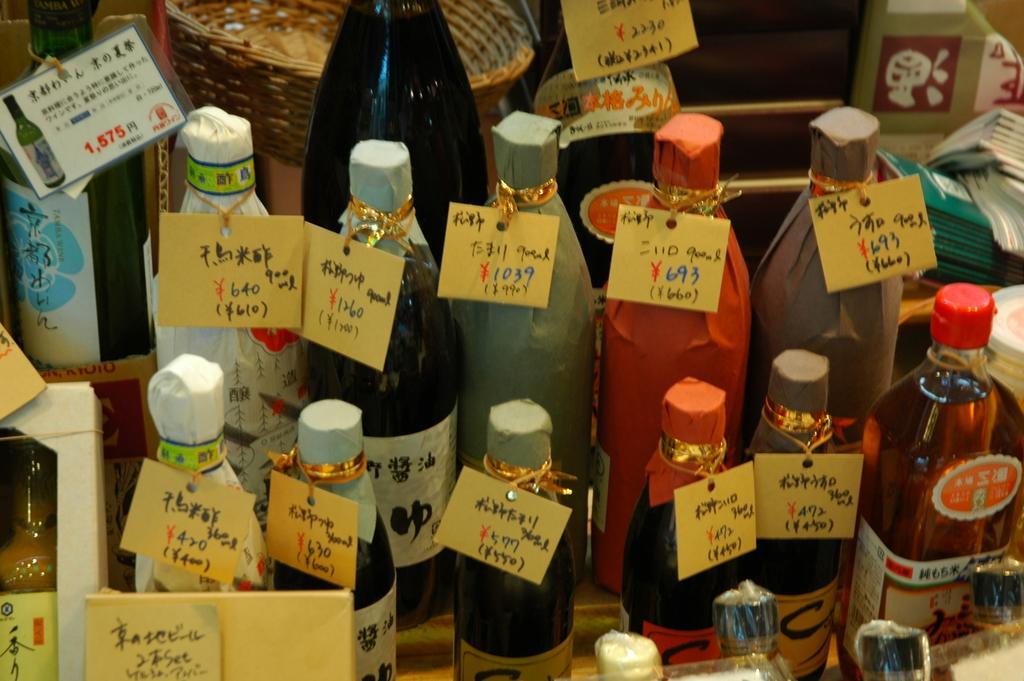Can you describe this image briefly? There are many bottles which has a tag attached to it and the tag contains the price of the bottle. 